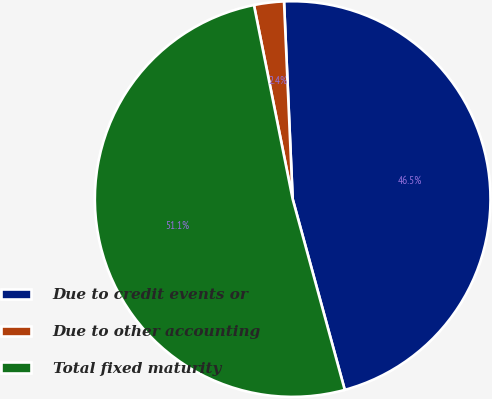<chart> <loc_0><loc_0><loc_500><loc_500><pie_chart><fcel>Due to credit events or<fcel>Due to other accounting<fcel>Total fixed maturity<nl><fcel>46.45%<fcel>2.44%<fcel>51.1%<nl></chart> 